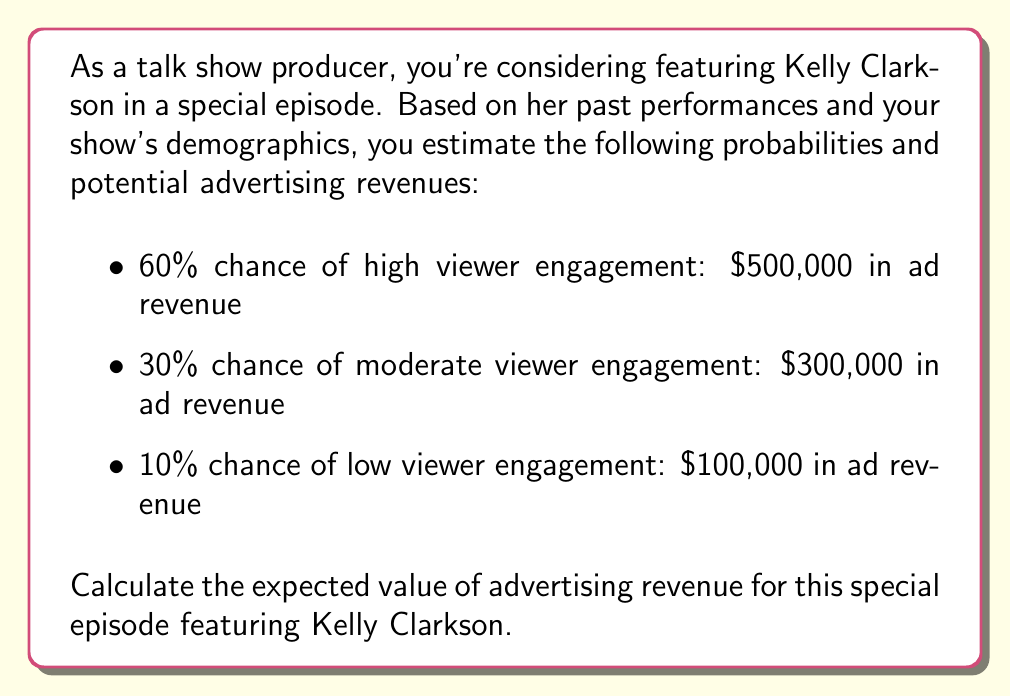Can you solve this math problem? To solve this problem, we need to use the concept of expected value from decision theory. The expected value is calculated by multiplying each possible outcome by its probability and then summing these products.

Let's break down the calculation step-by-step:

1. High viewer engagement:
   Probability = 60% = 0.6
   Revenue = $500,000
   Expected value = $500,000 * 0.6 = $300,000

2. Moderate viewer engagement:
   Probability = 30% = 0.3
   Revenue = $300,000
   Expected value = $300,000 * 0.3 = $90,000

3. Low viewer engagement:
   Probability = 10% = 0.1
   Revenue = $100,000
   Expected value = $100,000 * 0.1 = $10,000

Now, we sum these expected values:

$$ E(Revenue) = 300,000 + 90,000 + 10,000 = 400,000 $$

Therefore, the expected value of advertising revenue for the special episode featuring Kelly Clarkson is $400,000.

We can also express this calculation using the expected value formula:

$$ E(X) = \sum_{i=1}^{n} x_i \cdot p(x_i) $$

Where $x_i$ represents each possible outcome and $p(x_i)$ represents the probability of that outcome.

$$ E(Revenue) = 500,000 \cdot 0.6 + 300,000 \cdot 0.3 + 100,000 \cdot 0.1 = 400,000 $$
Answer: $400,000 